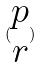Convert formula to latex. <formula><loc_0><loc_0><loc_500><loc_500>( \begin{matrix} p \\ r \end{matrix} )</formula> 